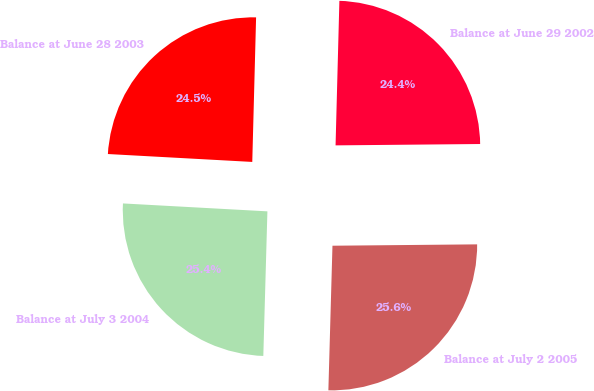<chart> <loc_0><loc_0><loc_500><loc_500><pie_chart><fcel>Balance at June 29 2002<fcel>Balance at June 28 2003<fcel>Balance at July 3 2004<fcel>Balance at July 2 2005<nl><fcel>24.43%<fcel>24.55%<fcel>25.42%<fcel>25.6%<nl></chart> 